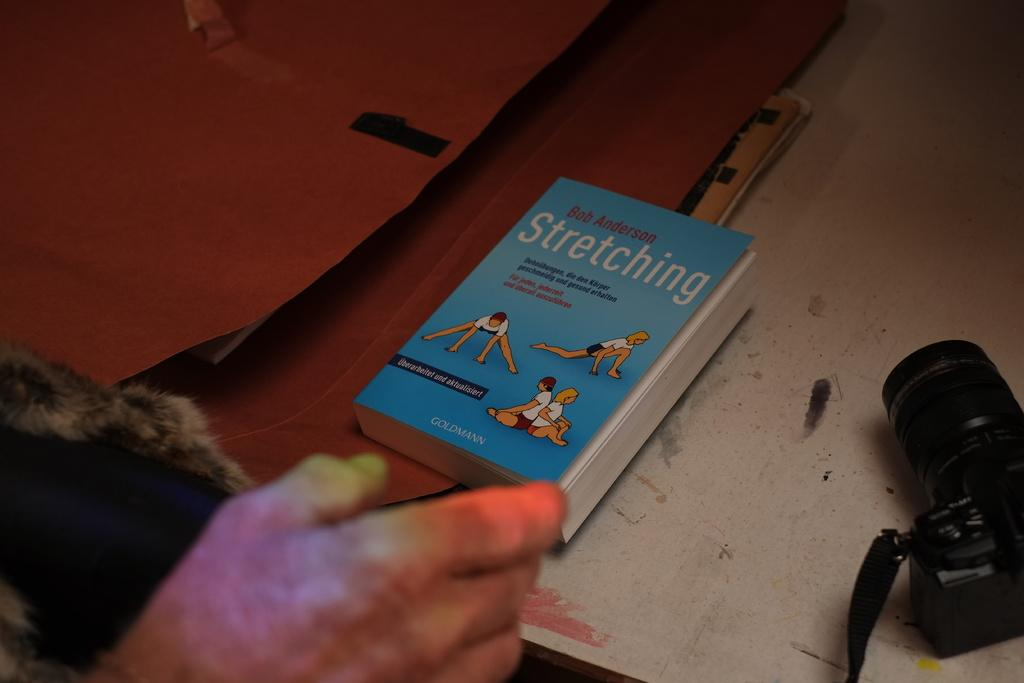Provide a one-sentence caption for the provided image. A book about stretching written by Bob Anderson. 